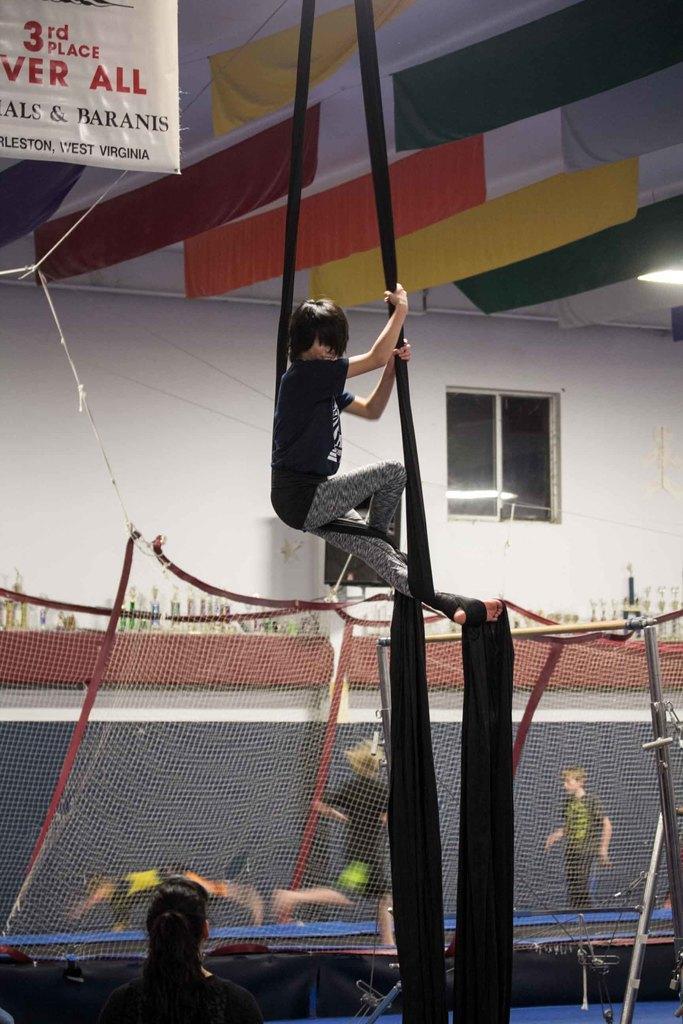Could you give a brief overview of what you see in this image? In this image a person is in air. He is holding a cloth which is tied to his leg. Few persons are behind the net. A woman is at the bottom of image. Background there is wall having window. Few shields are on the shelf. Few clothes and banner are hanged from the roof. 